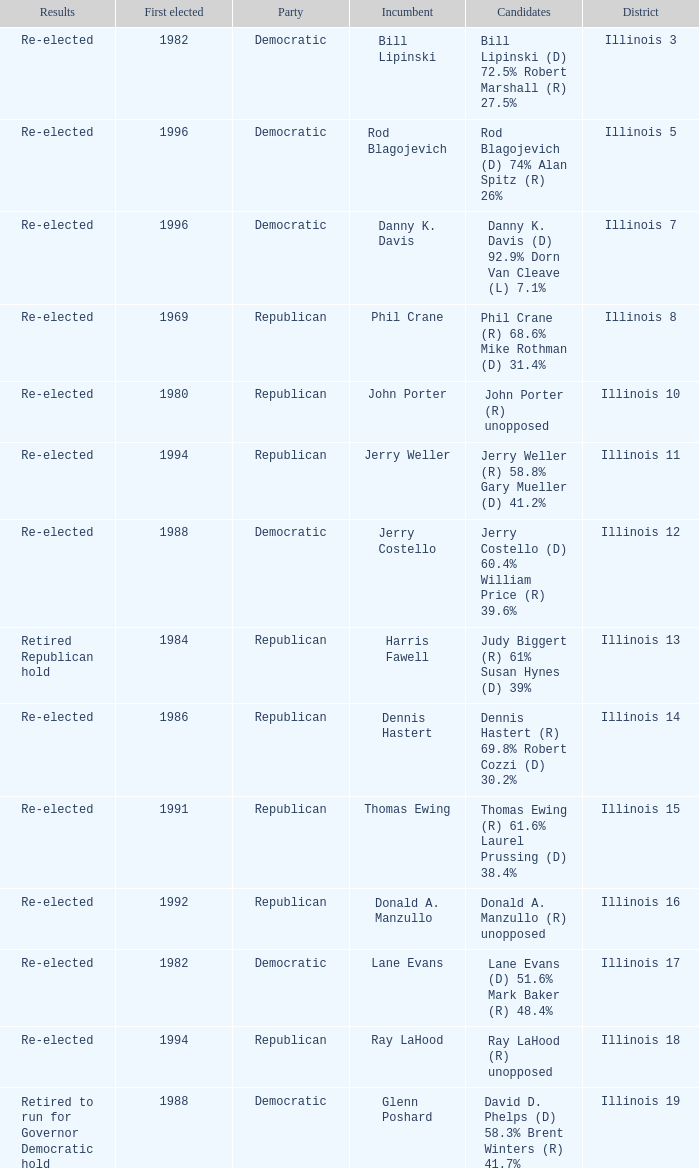What was the result in Illinois 7? Re-elected. 